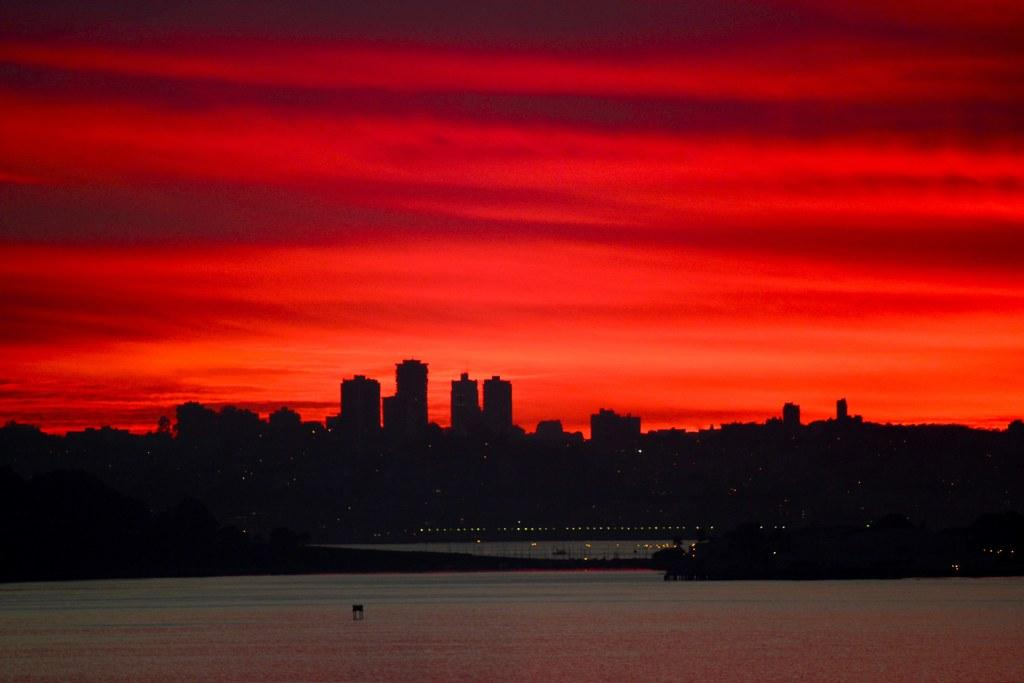What is present at the bottom of the image? There is water at the bottom of the image. What can be seen in the background of the image? There are buildings in the background of the image. What else is visible in the image besides the water and buildings? There are lights visible in the image. What is visible at the top of the image? The sky is visible at the top of the image. Where is the toothbrush located in the image? There is no toothbrush present in the image. What type of regret can be seen in the image? There is no regret depicted in the image; it features water, buildings, lights, and the sky. 